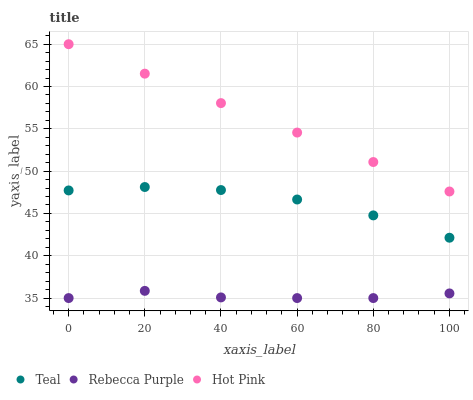Does Rebecca Purple have the minimum area under the curve?
Answer yes or no. Yes. Does Hot Pink have the maximum area under the curve?
Answer yes or no. Yes. Does Teal have the minimum area under the curve?
Answer yes or no. No. Does Teal have the maximum area under the curve?
Answer yes or no. No. Is Hot Pink the smoothest?
Answer yes or no. Yes. Is Teal the roughest?
Answer yes or no. Yes. Is Rebecca Purple the smoothest?
Answer yes or no. No. Is Rebecca Purple the roughest?
Answer yes or no. No. Does Rebecca Purple have the lowest value?
Answer yes or no. Yes. Does Teal have the lowest value?
Answer yes or no. No. Does Hot Pink have the highest value?
Answer yes or no. Yes. Does Teal have the highest value?
Answer yes or no. No. Is Rebecca Purple less than Hot Pink?
Answer yes or no. Yes. Is Hot Pink greater than Rebecca Purple?
Answer yes or no. Yes. Does Rebecca Purple intersect Hot Pink?
Answer yes or no. No. 